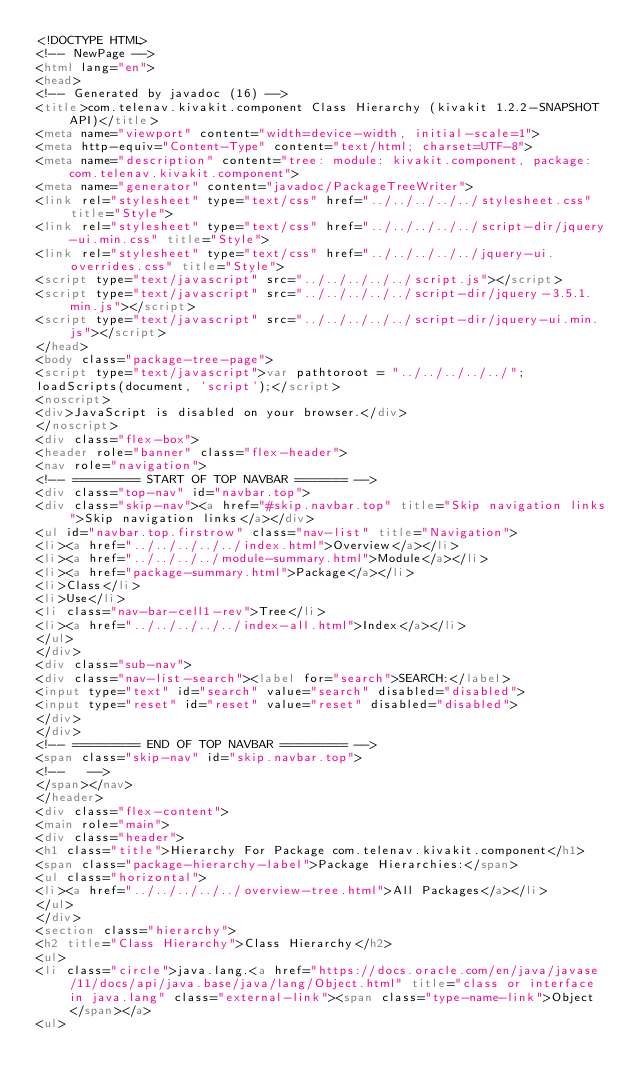<code> <loc_0><loc_0><loc_500><loc_500><_HTML_><!DOCTYPE HTML>
<!-- NewPage -->
<html lang="en">
<head>
<!-- Generated by javadoc (16) -->
<title>com.telenav.kivakit.component Class Hierarchy (kivakit 1.2.2-SNAPSHOT API)</title>
<meta name="viewport" content="width=device-width, initial-scale=1">
<meta http-equiv="Content-Type" content="text/html; charset=UTF-8">
<meta name="description" content="tree: module: kivakit.component, package: com.telenav.kivakit.component">
<meta name="generator" content="javadoc/PackageTreeWriter">
<link rel="stylesheet" type="text/css" href="../../../../../stylesheet.css" title="Style">
<link rel="stylesheet" type="text/css" href="../../../../../script-dir/jquery-ui.min.css" title="Style">
<link rel="stylesheet" type="text/css" href="../../../../../jquery-ui.overrides.css" title="Style">
<script type="text/javascript" src="../../../../../script.js"></script>
<script type="text/javascript" src="../../../../../script-dir/jquery-3.5.1.min.js"></script>
<script type="text/javascript" src="../../../../../script-dir/jquery-ui.min.js"></script>
</head>
<body class="package-tree-page">
<script type="text/javascript">var pathtoroot = "../../../../../";
loadScripts(document, 'script');</script>
<noscript>
<div>JavaScript is disabled on your browser.</div>
</noscript>
<div class="flex-box">
<header role="banner" class="flex-header">
<nav role="navigation">
<!-- ========= START OF TOP NAVBAR ======= -->
<div class="top-nav" id="navbar.top">
<div class="skip-nav"><a href="#skip.navbar.top" title="Skip navigation links">Skip navigation links</a></div>
<ul id="navbar.top.firstrow" class="nav-list" title="Navigation">
<li><a href="../../../../../index.html">Overview</a></li>
<li><a href="../../../../module-summary.html">Module</a></li>
<li><a href="package-summary.html">Package</a></li>
<li>Class</li>
<li>Use</li>
<li class="nav-bar-cell1-rev">Tree</li>
<li><a href="../../../../../index-all.html">Index</a></li>
</ul>
</div>
<div class="sub-nav">
<div class="nav-list-search"><label for="search">SEARCH:</label>
<input type="text" id="search" value="search" disabled="disabled">
<input type="reset" id="reset" value="reset" disabled="disabled">
</div>
</div>
<!-- ========= END OF TOP NAVBAR ========= -->
<span class="skip-nav" id="skip.navbar.top">
<!--   -->
</span></nav>
</header>
<div class="flex-content">
<main role="main">
<div class="header">
<h1 class="title">Hierarchy For Package com.telenav.kivakit.component</h1>
<span class="package-hierarchy-label">Package Hierarchies:</span>
<ul class="horizontal">
<li><a href="../../../../../overview-tree.html">All Packages</a></li>
</ul>
</div>
<section class="hierarchy">
<h2 title="Class Hierarchy">Class Hierarchy</h2>
<ul>
<li class="circle">java.lang.<a href="https://docs.oracle.com/en/java/javase/11/docs/api/java.base/java/lang/Object.html" title="class or interface in java.lang" class="external-link"><span class="type-name-link">Object</span></a>
<ul></code> 